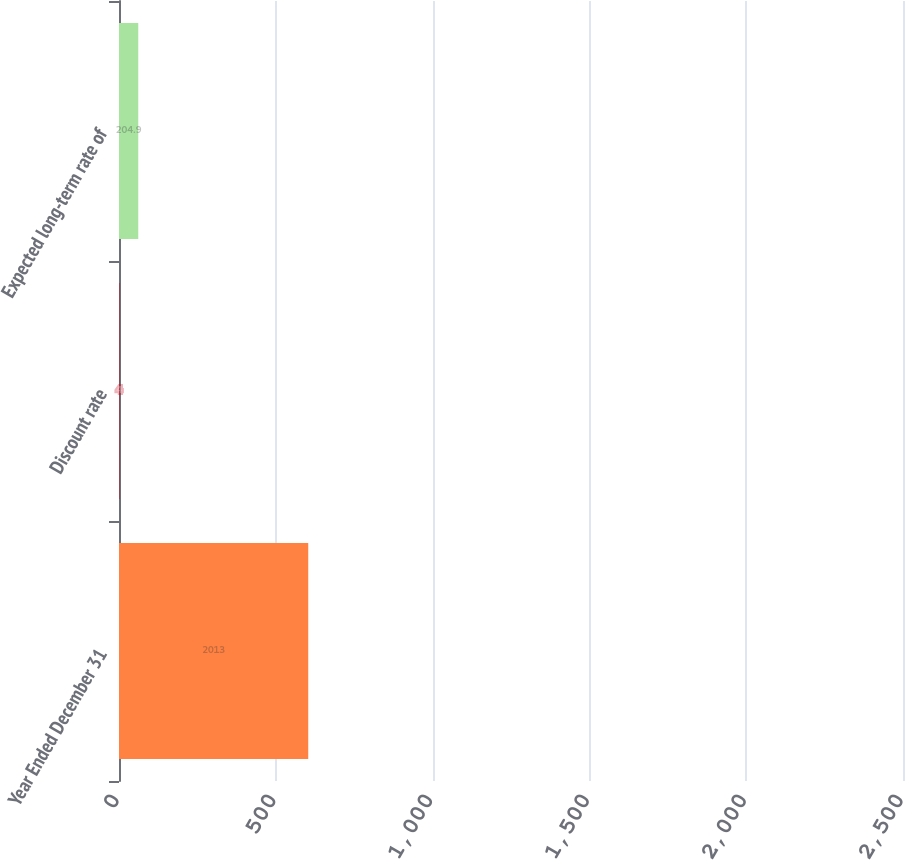Convert chart to OTSL. <chart><loc_0><loc_0><loc_500><loc_500><bar_chart><fcel>Year Ended December 31<fcel>Discount rate<fcel>Expected long-term rate of<nl><fcel>2013<fcel>4<fcel>204.9<nl></chart> 